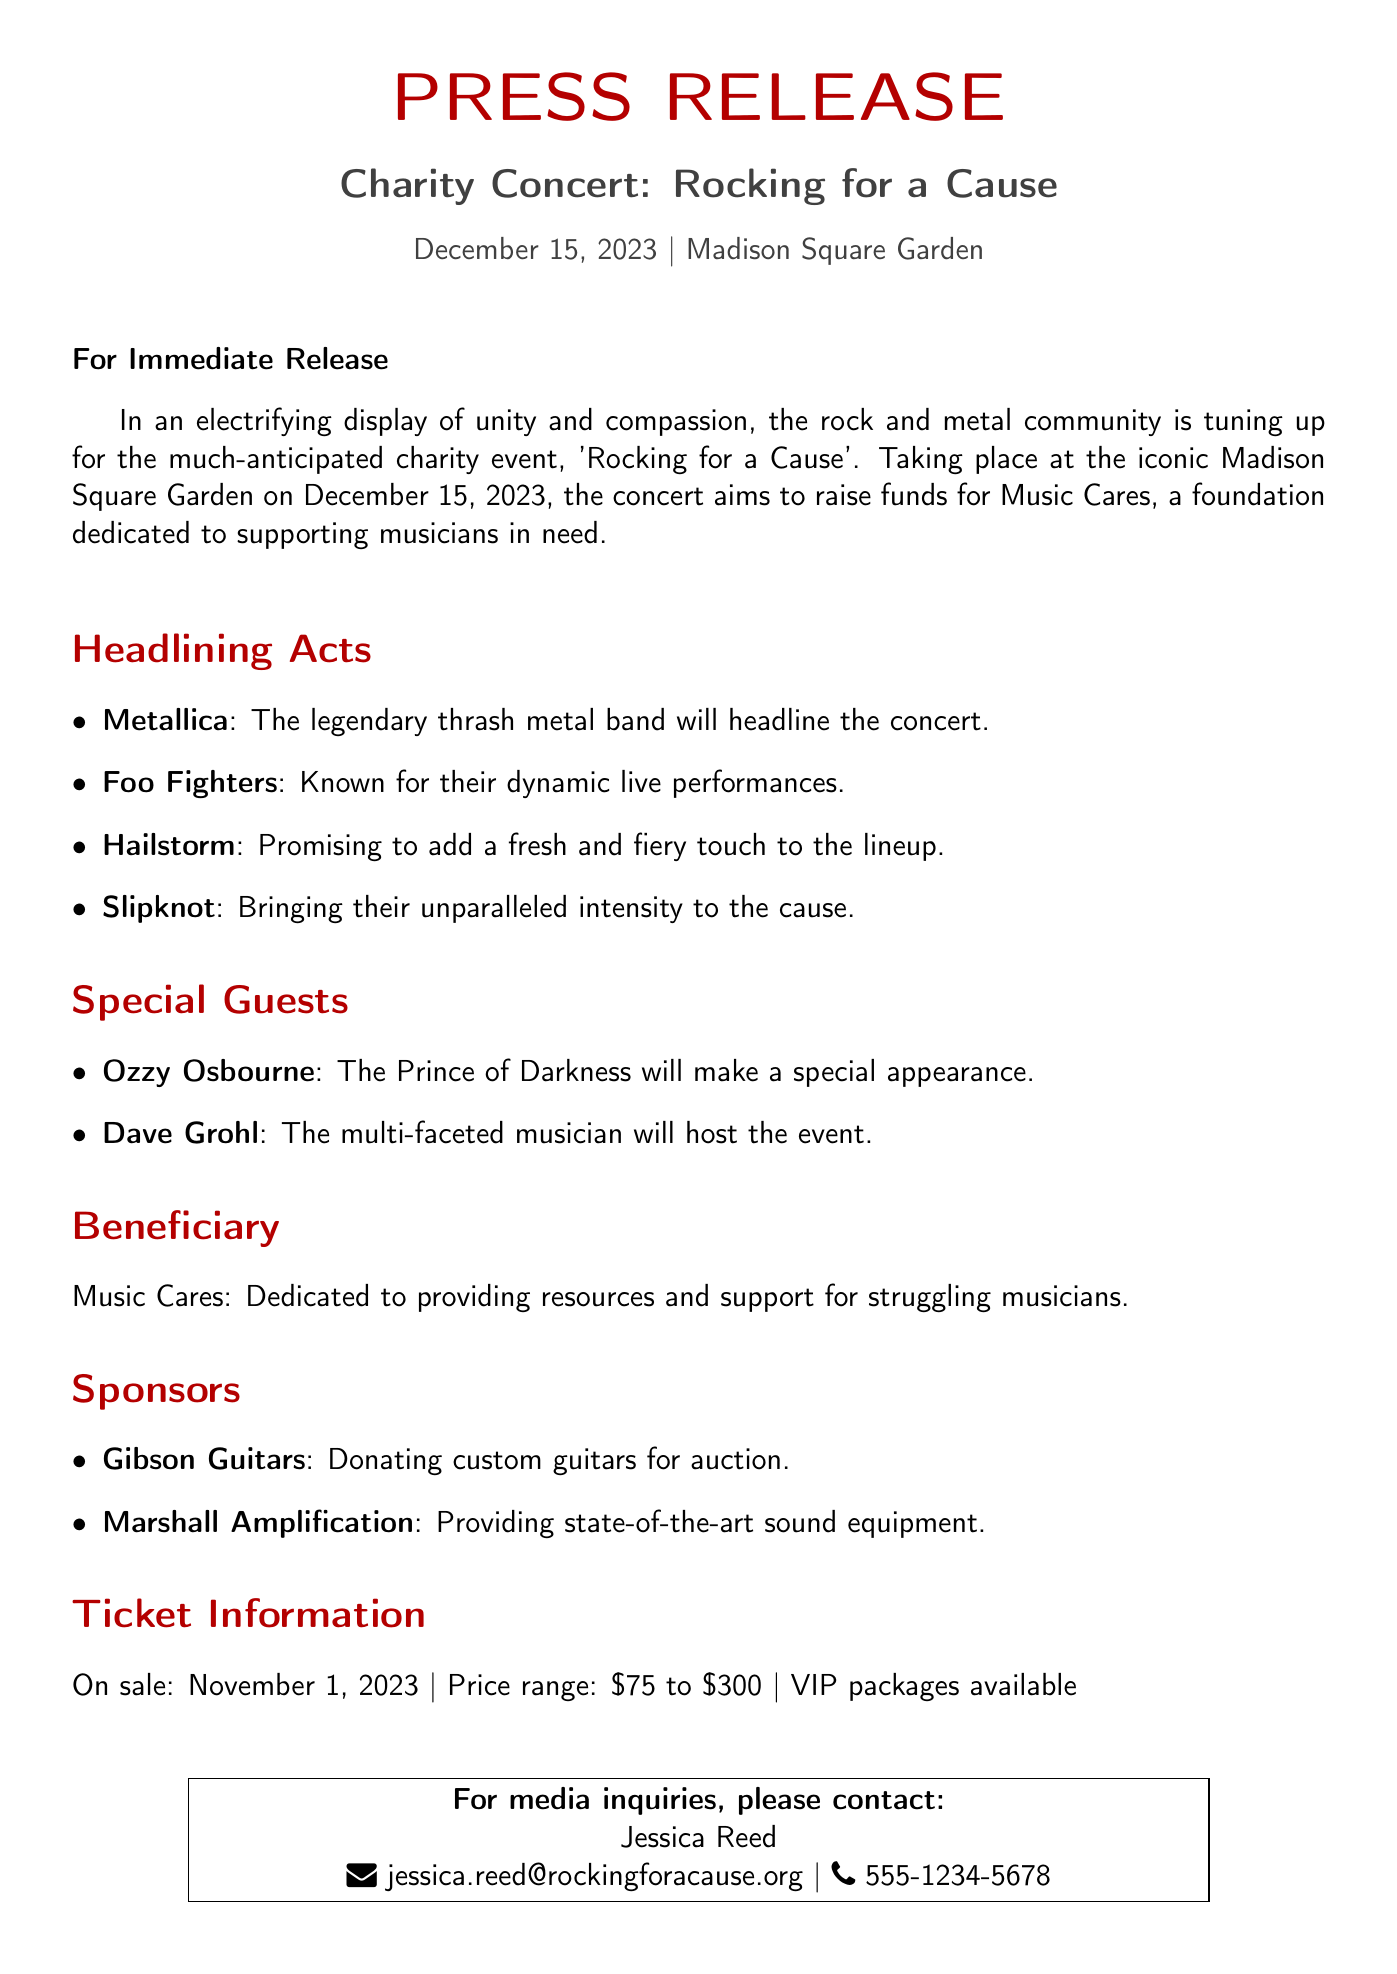What is the date of the concert? The concert is scheduled for December 15, 2023.
Answer: December 15, 2023 Who are the headlining acts? The document lists Metallica, Foo Fighters, Hailstorm, and Slipknot as the headlining acts.
Answer: Metallica, Foo Fighters, Hailstorm, and Slipknot What is the price range for tickets? The price range for tickets is specified in the document as between $75 and $300.
Answer: $75 to $300 Who is hosting the event? The document states that Dave Grohl will host the event.
Answer: Dave Grohl What is the name of the foundation benefiting from the concert? The foundation mentioned in the document is Music Cares.
Answer: Music Cares How is the event described in terms of its objective? The concert aims to raise funds for musicians in need as represented in the document.
Answer: To raise funds for musicians in need What will Gibson Guitars donate for the event? The document mentions that Gibson Guitars will donate custom guitars for auction.
Answer: Custom guitars for auction What type of performance is Slipknot known for? The document describes Slipknot as bringing unparalleled intensity to the concert.
Answer: Unparalleled intensity What are the VIP packages referred to? The document notes that VIP packages are available for concertgoers.
Answer: VIP packages available 